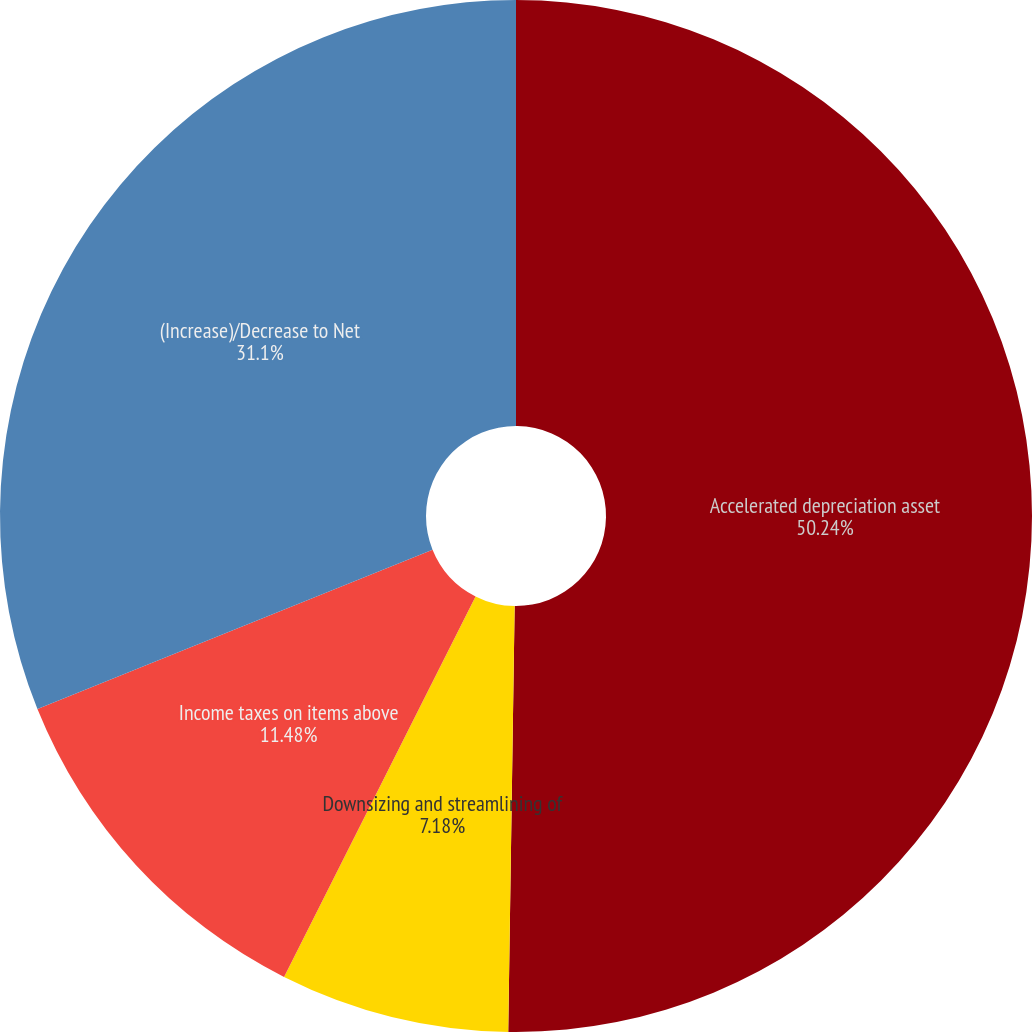<chart> <loc_0><loc_0><loc_500><loc_500><pie_chart><fcel>Accelerated depreciation asset<fcel>Downsizing and streamlining of<fcel>Income taxes on items above<fcel>(Increase)/Decrease to Net<nl><fcel>50.24%<fcel>7.18%<fcel>11.48%<fcel>31.1%<nl></chart> 